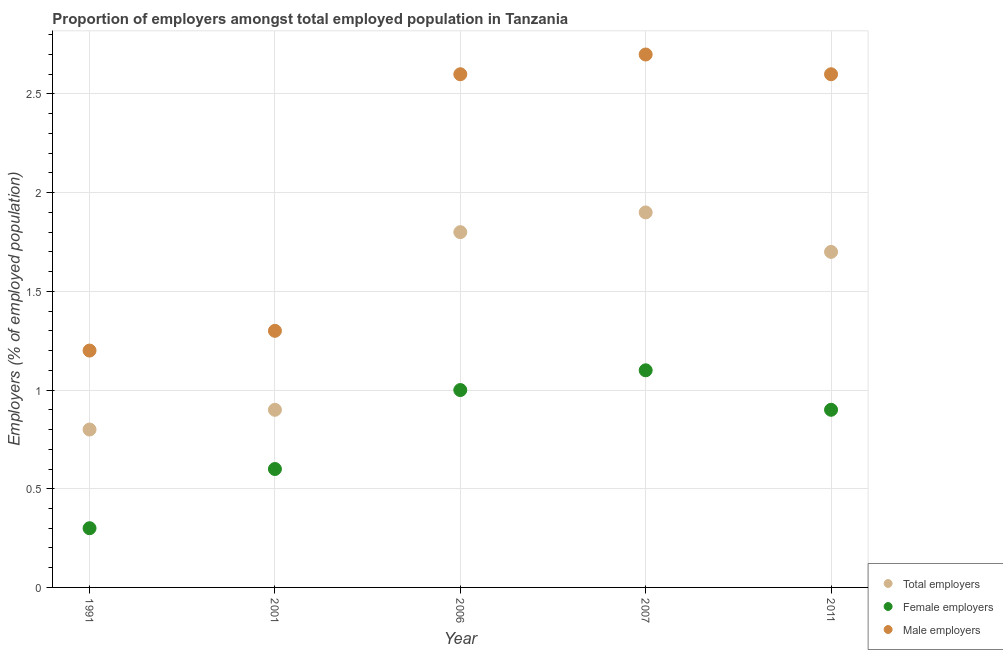How many different coloured dotlines are there?
Ensure brevity in your answer.  3. Is the number of dotlines equal to the number of legend labels?
Your answer should be very brief. Yes. What is the percentage of male employers in 2006?
Keep it short and to the point. 2.6. Across all years, what is the maximum percentage of female employers?
Offer a terse response. 1.1. Across all years, what is the minimum percentage of male employers?
Ensure brevity in your answer.  1.2. What is the total percentage of total employers in the graph?
Provide a short and direct response. 7.1. What is the difference between the percentage of male employers in 1991 and that in 2001?
Keep it short and to the point. -0.1. What is the average percentage of total employers per year?
Provide a short and direct response. 1.42. In the year 2001, what is the difference between the percentage of female employers and percentage of male employers?
Ensure brevity in your answer.  -0.7. In how many years, is the percentage of male employers greater than 0.4 %?
Keep it short and to the point. 5. What is the ratio of the percentage of total employers in 2001 to that in 2006?
Your response must be concise. 0.5. Is the percentage of male employers in 2001 less than that in 2006?
Your answer should be compact. Yes. What is the difference between the highest and the second highest percentage of total employers?
Your answer should be compact. 0.1. What is the difference between the highest and the lowest percentage of male employers?
Provide a short and direct response. 1.5. Does the percentage of female employers monotonically increase over the years?
Your answer should be very brief. No. Is the percentage of total employers strictly greater than the percentage of female employers over the years?
Offer a very short reply. Yes. Is the percentage of total employers strictly less than the percentage of male employers over the years?
Make the answer very short. Yes. What is the difference between two consecutive major ticks on the Y-axis?
Your answer should be compact. 0.5. Does the graph contain any zero values?
Provide a short and direct response. No. What is the title of the graph?
Provide a short and direct response. Proportion of employers amongst total employed population in Tanzania. What is the label or title of the Y-axis?
Your answer should be very brief. Employers (% of employed population). What is the Employers (% of employed population) of Total employers in 1991?
Your answer should be very brief. 0.8. What is the Employers (% of employed population) in Female employers in 1991?
Your response must be concise. 0.3. What is the Employers (% of employed population) of Male employers in 1991?
Ensure brevity in your answer.  1.2. What is the Employers (% of employed population) of Total employers in 2001?
Your answer should be very brief. 0.9. What is the Employers (% of employed population) in Female employers in 2001?
Make the answer very short. 0.6. What is the Employers (% of employed population) of Male employers in 2001?
Make the answer very short. 1.3. What is the Employers (% of employed population) in Total employers in 2006?
Make the answer very short. 1.8. What is the Employers (% of employed population) of Male employers in 2006?
Provide a short and direct response. 2.6. What is the Employers (% of employed population) of Total employers in 2007?
Your answer should be compact. 1.9. What is the Employers (% of employed population) in Female employers in 2007?
Give a very brief answer. 1.1. What is the Employers (% of employed population) in Male employers in 2007?
Provide a succinct answer. 2.7. What is the Employers (% of employed population) of Total employers in 2011?
Make the answer very short. 1.7. What is the Employers (% of employed population) of Female employers in 2011?
Your answer should be compact. 0.9. What is the Employers (% of employed population) of Male employers in 2011?
Your response must be concise. 2.6. Across all years, what is the maximum Employers (% of employed population) in Total employers?
Give a very brief answer. 1.9. Across all years, what is the maximum Employers (% of employed population) of Female employers?
Offer a very short reply. 1.1. Across all years, what is the maximum Employers (% of employed population) in Male employers?
Your response must be concise. 2.7. Across all years, what is the minimum Employers (% of employed population) in Total employers?
Your answer should be very brief. 0.8. Across all years, what is the minimum Employers (% of employed population) in Female employers?
Give a very brief answer. 0.3. Across all years, what is the minimum Employers (% of employed population) of Male employers?
Provide a short and direct response. 1.2. What is the total Employers (% of employed population) of Female employers in the graph?
Your response must be concise. 3.9. What is the difference between the Employers (% of employed population) of Female employers in 1991 and that in 2001?
Provide a succinct answer. -0.3. What is the difference between the Employers (% of employed population) of Male employers in 1991 and that in 2001?
Make the answer very short. -0.1. What is the difference between the Employers (% of employed population) in Total employers in 1991 and that in 2006?
Provide a succinct answer. -1. What is the difference between the Employers (% of employed population) in Total employers in 1991 and that in 2007?
Your answer should be very brief. -1.1. What is the difference between the Employers (% of employed population) in Female employers in 1991 and that in 2007?
Your answer should be compact. -0.8. What is the difference between the Employers (% of employed population) of Male employers in 1991 and that in 2007?
Offer a very short reply. -1.5. What is the difference between the Employers (% of employed population) in Male employers in 1991 and that in 2011?
Offer a very short reply. -1.4. What is the difference between the Employers (% of employed population) of Female employers in 2001 and that in 2006?
Your answer should be very brief. -0.4. What is the difference between the Employers (% of employed population) of Male employers in 2001 and that in 2006?
Provide a short and direct response. -1.3. What is the difference between the Employers (% of employed population) of Total employers in 2001 and that in 2007?
Provide a short and direct response. -1. What is the difference between the Employers (% of employed population) in Male employers in 2001 and that in 2007?
Keep it short and to the point. -1.4. What is the difference between the Employers (% of employed population) in Female employers in 2001 and that in 2011?
Provide a short and direct response. -0.3. What is the difference between the Employers (% of employed population) of Male employers in 2001 and that in 2011?
Provide a succinct answer. -1.3. What is the difference between the Employers (% of employed population) in Female employers in 2006 and that in 2007?
Your answer should be compact. -0.1. What is the difference between the Employers (% of employed population) of Total employers in 2006 and that in 2011?
Ensure brevity in your answer.  0.1. What is the difference between the Employers (% of employed population) in Female employers in 2006 and that in 2011?
Provide a succinct answer. 0.1. What is the difference between the Employers (% of employed population) in Total employers in 2007 and that in 2011?
Keep it short and to the point. 0.2. What is the difference between the Employers (% of employed population) of Male employers in 2007 and that in 2011?
Offer a very short reply. 0.1. What is the difference between the Employers (% of employed population) in Total employers in 1991 and the Employers (% of employed population) in Male employers in 2001?
Provide a succinct answer. -0.5. What is the difference between the Employers (% of employed population) in Female employers in 1991 and the Employers (% of employed population) in Male employers in 2001?
Provide a succinct answer. -1. What is the difference between the Employers (% of employed population) in Total employers in 1991 and the Employers (% of employed population) in Female employers in 2006?
Provide a short and direct response. -0.2. What is the difference between the Employers (% of employed population) of Total employers in 1991 and the Employers (% of employed population) of Male employers in 2006?
Your response must be concise. -1.8. What is the difference between the Employers (% of employed population) of Total employers in 1991 and the Employers (% of employed population) of Male employers in 2007?
Offer a very short reply. -1.9. What is the difference between the Employers (% of employed population) of Female employers in 1991 and the Employers (% of employed population) of Male employers in 2007?
Your response must be concise. -2.4. What is the difference between the Employers (% of employed population) of Total employers in 2001 and the Employers (% of employed population) of Female employers in 2006?
Your answer should be very brief. -0.1. What is the difference between the Employers (% of employed population) in Total employers in 2001 and the Employers (% of employed population) in Male employers in 2011?
Keep it short and to the point. -1.7. What is the difference between the Employers (% of employed population) in Total employers in 2006 and the Employers (% of employed population) in Male employers in 2007?
Offer a very short reply. -0.9. What is the difference between the Employers (% of employed population) of Total employers in 2007 and the Employers (% of employed population) of Female employers in 2011?
Give a very brief answer. 1. What is the difference between the Employers (% of employed population) in Total employers in 2007 and the Employers (% of employed population) in Male employers in 2011?
Make the answer very short. -0.7. What is the average Employers (% of employed population) in Total employers per year?
Keep it short and to the point. 1.42. What is the average Employers (% of employed population) in Female employers per year?
Keep it short and to the point. 0.78. What is the average Employers (% of employed population) in Male employers per year?
Give a very brief answer. 2.08. In the year 1991, what is the difference between the Employers (% of employed population) in Total employers and Employers (% of employed population) in Male employers?
Offer a very short reply. -0.4. In the year 1991, what is the difference between the Employers (% of employed population) in Female employers and Employers (% of employed population) in Male employers?
Provide a succinct answer. -0.9. In the year 2001, what is the difference between the Employers (% of employed population) of Female employers and Employers (% of employed population) of Male employers?
Keep it short and to the point. -0.7. In the year 2006, what is the difference between the Employers (% of employed population) of Total employers and Employers (% of employed population) of Male employers?
Your answer should be very brief. -0.8. In the year 2006, what is the difference between the Employers (% of employed population) of Female employers and Employers (% of employed population) of Male employers?
Provide a succinct answer. -1.6. In the year 2007, what is the difference between the Employers (% of employed population) of Total employers and Employers (% of employed population) of Male employers?
Provide a succinct answer. -0.8. In the year 2011, what is the difference between the Employers (% of employed population) in Total employers and Employers (% of employed population) in Female employers?
Your answer should be very brief. 0.8. In the year 2011, what is the difference between the Employers (% of employed population) in Total employers and Employers (% of employed population) in Male employers?
Keep it short and to the point. -0.9. In the year 2011, what is the difference between the Employers (% of employed population) in Female employers and Employers (% of employed population) in Male employers?
Offer a very short reply. -1.7. What is the ratio of the Employers (% of employed population) in Total employers in 1991 to that in 2001?
Offer a very short reply. 0.89. What is the ratio of the Employers (% of employed population) of Male employers in 1991 to that in 2001?
Provide a short and direct response. 0.92. What is the ratio of the Employers (% of employed population) of Total employers in 1991 to that in 2006?
Ensure brevity in your answer.  0.44. What is the ratio of the Employers (% of employed population) of Male employers in 1991 to that in 2006?
Your answer should be compact. 0.46. What is the ratio of the Employers (% of employed population) in Total employers in 1991 to that in 2007?
Provide a short and direct response. 0.42. What is the ratio of the Employers (% of employed population) of Female employers in 1991 to that in 2007?
Give a very brief answer. 0.27. What is the ratio of the Employers (% of employed population) in Male employers in 1991 to that in 2007?
Provide a succinct answer. 0.44. What is the ratio of the Employers (% of employed population) of Total employers in 1991 to that in 2011?
Provide a short and direct response. 0.47. What is the ratio of the Employers (% of employed population) in Female employers in 1991 to that in 2011?
Your answer should be very brief. 0.33. What is the ratio of the Employers (% of employed population) in Male employers in 1991 to that in 2011?
Give a very brief answer. 0.46. What is the ratio of the Employers (% of employed population) of Male employers in 2001 to that in 2006?
Offer a terse response. 0.5. What is the ratio of the Employers (% of employed population) in Total employers in 2001 to that in 2007?
Your answer should be very brief. 0.47. What is the ratio of the Employers (% of employed population) of Female employers in 2001 to that in 2007?
Give a very brief answer. 0.55. What is the ratio of the Employers (% of employed population) of Male employers in 2001 to that in 2007?
Your answer should be compact. 0.48. What is the ratio of the Employers (% of employed population) in Total employers in 2001 to that in 2011?
Provide a short and direct response. 0.53. What is the ratio of the Employers (% of employed population) in Female employers in 2001 to that in 2011?
Give a very brief answer. 0.67. What is the ratio of the Employers (% of employed population) in Female employers in 2006 to that in 2007?
Offer a very short reply. 0.91. What is the ratio of the Employers (% of employed population) in Male employers in 2006 to that in 2007?
Provide a short and direct response. 0.96. What is the ratio of the Employers (% of employed population) in Total employers in 2006 to that in 2011?
Offer a very short reply. 1.06. What is the ratio of the Employers (% of employed population) of Male employers in 2006 to that in 2011?
Offer a very short reply. 1. What is the ratio of the Employers (% of employed population) in Total employers in 2007 to that in 2011?
Provide a succinct answer. 1.12. What is the ratio of the Employers (% of employed population) of Female employers in 2007 to that in 2011?
Provide a succinct answer. 1.22. What is the difference between the highest and the second highest Employers (% of employed population) in Female employers?
Ensure brevity in your answer.  0.1. What is the difference between the highest and the lowest Employers (% of employed population) of Total employers?
Offer a terse response. 1.1. 